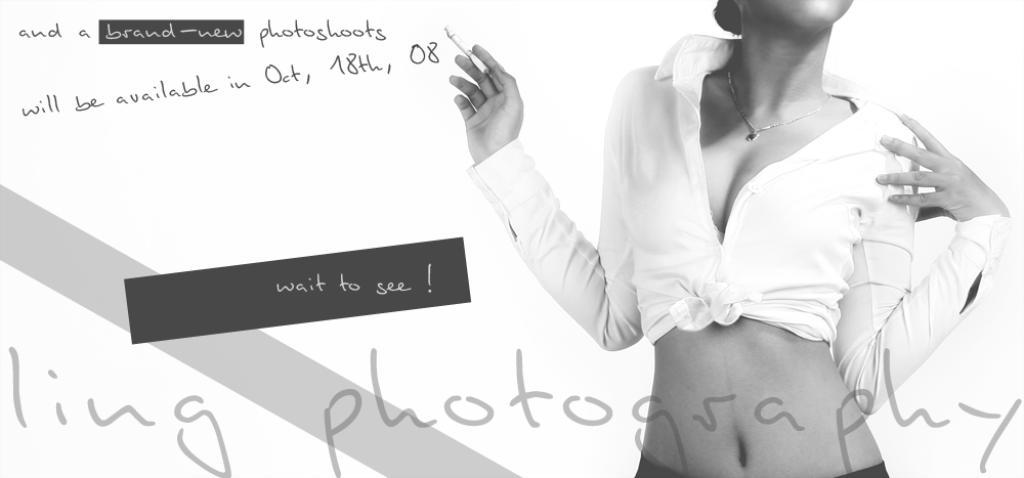What is the color scheme of the image? The image is black and white. What can be seen on the right side of the image? There is a person on the right side of the image. What is present on the left side of the image? There is text on the left side of the image. How was the image manipulated or altered? The image is edited. What is the relation between the person and the mom in the image? There is no mom present in the image, as the facts provided do not mention a mom or any relation between the person and a mom. 